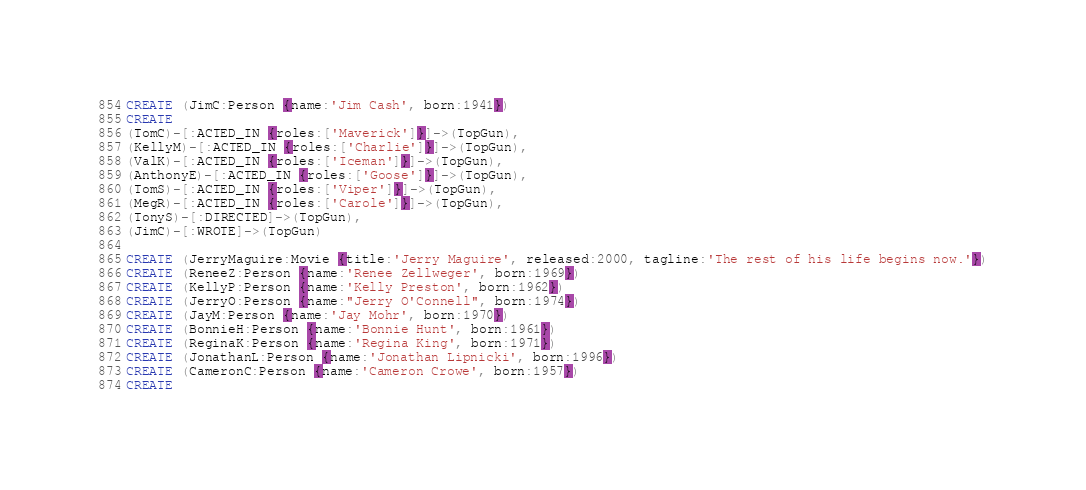Convert code to text. <code><loc_0><loc_0><loc_500><loc_500><_SQL_>CREATE (JimC:Person {name:'Jim Cash', born:1941})
CREATE
(TomC)-[:ACTED_IN {roles:['Maverick']}]->(TopGun),
(KellyM)-[:ACTED_IN {roles:['Charlie']}]->(TopGun),
(ValK)-[:ACTED_IN {roles:['Iceman']}]->(TopGun),
(AnthonyE)-[:ACTED_IN {roles:['Goose']}]->(TopGun),
(TomS)-[:ACTED_IN {roles:['Viper']}]->(TopGun),
(MegR)-[:ACTED_IN {roles:['Carole']}]->(TopGun),
(TonyS)-[:DIRECTED]->(TopGun),
(JimC)-[:WROTE]->(TopGun)

CREATE (JerryMaguire:Movie {title:'Jerry Maguire', released:2000, tagline:'The rest of his life begins now.'})
CREATE (ReneeZ:Person {name:'Renee Zellweger', born:1969})
CREATE (KellyP:Person {name:'Kelly Preston', born:1962})
CREATE (JerryO:Person {name:"Jerry O'Connell", born:1974})
CREATE (JayM:Person {name:'Jay Mohr', born:1970})
CREATE (BonnieH:Person {name:'Bonnie Hunt', born:1961})
CREATE (ReginaK:Person {name:'Regina King', born:1971})
CREATE (JonathanL:Person {name:'Jonathan Lipnicki', born:1996})
CREATE (CameronC:Person {name:'Cameron Crowe', born:1957})
CREATE</code> 